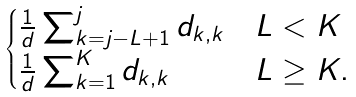Convert formula to latex. <formula><loc_0><loc_0><loc_500><loc_500>\begin{cases} \frac { 1 } { d } \sum _ { k = j - L + 1 } ^ { j } d _ { k , k } & L < K \\ \frac { 1 } { d } \sum _ { k = 1 } ^ { K } d _ { k , k } & L \geq K . \end{cases}</formula> 